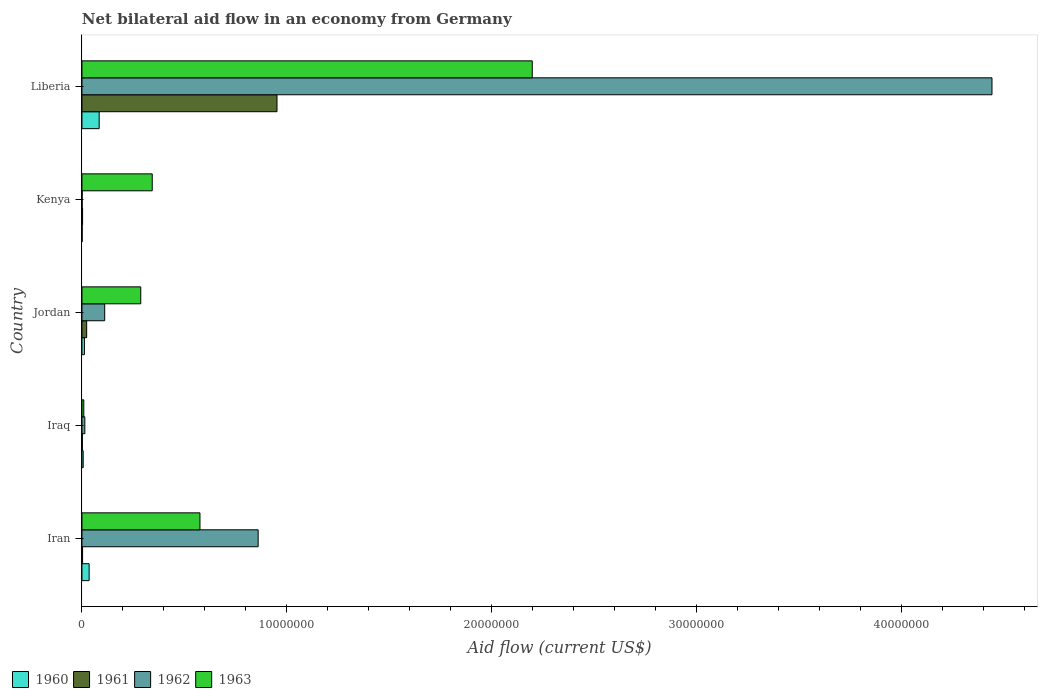How many different coloured bars are there?
Give a very brief answer. 4. Are the number of bars per tick equal to the number of legend labels?
Give a very brief answer. Yes. How many bars are there on the 1st tick from the top?
Your answer should be very brief. 4. What is the label of the 1st group of bars from the top?
Give a very brief answer. Liberia. In how many cases, is the number of bars for a given country not equal to the number of legend labels?
Offer a very short reply. 0. Across all countries, what is the maximum net bilateral aid flow in 1962?
Ensure brevity in your answer.  4.44e+07. In which country was the net bilateral aid flow in 1961 maximum?
Your answer should be very brief. Liberia. In which country was the net bilateral aid flow in 1963 minimum?
Provide a succinct answer. Iraq. What is the total net bilateral aid flow in 1962 in the graph?
Provide a short and direct response. 5.43e+07. What is the difference between the net bilateral aid flow in 1963 in Jordan and the net bilateral aid flow in 1962 in Liberia?
Offer a very short reply. -4.16e+07. What is the average net bilateral aid flow in 1961 per country?
Give a very brief answer. 1.97e+06. What is the difference between the net bilateral aid flow in 1962 and net bilateral aid flow in 1961 in Liberia?
Provide a short and direct response. 3.49e+07. What is the ratio of the net bilateral aid flow in 1962 in Kenya to that in Liberia?
Your answer should be very brief. 0. Is the difference between the net bilateral aid flow in 1962 in Iraq and Jordan greater than the difference between the net bilateral aid flow in 1961 in Iraq and Jordan?
Your answer should be compact. No. What is the difference between the highest and the second highest net bilateral aid flow in 1961?
Make the answer very short. 9.29e+06. What is the difference between the highest and the lowest net bilateral aid flow in 1960?
Your answer should be very brief. 8.30e+05. Is it the case that in every country, the sum of the net bilateral aid flow in 1961 and net bilateral aid flow in 1962 is greater than the sum of net bilateral aid flow in 1960 and net bilateral aid flow in 1963?
Ensure brevity in your answer.  No. What does the 3rd bar from the top in Iraq represents?
Provide a succinct answer. 1961. Is it the case that in every country, the sum of the net bilateral aid flow in 1961 and net bilateral aid flow in 1963 is greater than the net bilateral aid flow in 1960?
Provide a short and direct response. Yes. Are all the bars in the graph horizontal?
Make the answer very short. Yes. Are the values on the major ticks of X-axis written in scientific E-notation?
Offer a very short reply. No. Where does the legend appear in the graph?
Keep it short and to the point. Bottom left. How many legend labels are there?
Your answer should be very brief. 4. What is the title of the graph?
Ensure brevity in your answer.  Net bilateral aid flow in an economy from Germany. What is the Aid flow (current US$) of 1960 in Iran?
Your answer should be very brief. 3.50e+05. What is the Aid flow (current US$) in 1961 in Iran?
Offer a very short reply. 3.00e+04. What is the Aid flow (current US$) in 1962 in Iran?
Make the answer very short. 8.60e+06. What is the Aid flow (current US$) in 1963 in Iran?
Ensure brevity in your answer.  5.76e+06. What is the Aid flow (current US$) of 1963 in Iraq?
Your answer should be compact. 9.00e+04. What is the Aid flow (current US$) in 1960 in Jordan?
Give a very brief answer. 1.20e+05. What is the Aid flow (current US$) of 1962 in Jordan?
Make the answer very short. 1.11e+06. What is the Aid flow (current US$) of 1963 in Jordan?
Provide a short and direct response. 2.87e+06. What is the Aid flow (current US$) in 1960 in Kenya?
Give a very brief answer. 10000. What is the Aid flow (current US$) of 1963 in Kenya?
Your response must be concise. 3.43e+06. What is the Aid flow (current US$) in 1960 in Liberia?
Offer a very short reply. 8.40e+05. What is the Aid flow (current US$) in 1961 in Liberia?
Provide a short and direct response. 9.52e+06. What is the Aid flow (current US$) of 1962 in Liberia?
Make the answer very short. 4.44e+07. What is the Aid flow (current US$) of 1963 in Liberia?
Give a very brief answer. 2.20e+07. Across all countries, what is the maximum Aid flow (current US$) of 1960?
Provide a succinct answer. 8.40e+05. Across all countries, what is the maximum Aid flow (current US$) in 1961?
Keep it short and to the point. 9.52e+06. Across all countries, what is the maximum Aid flow (current US$) of 1962?
Your answer should be very brief. 4.44e+07. Across all countries, what is the maximum Aid flow (current US$) in 1963?
Provide a succinct answer. 2.20e+07. Across all countries, what is the minimum Aid flow (current US$) of 1962?
Your answer should be very brief. 10000. What is the total Aid flow (current US$) of 1960 in the graph?
Provide a short and direct response. 1.38e+06. What is the total Aid flow (current US$) of 1961 in the graph?
Make the answer very short. 9.83e+06. What is the total Aid flow (current US$) of 1962 in the graph?
Offer a terse response. 5.43e+07. What is the total Aid flow (current US$) in 1963 in the graph?
Keep it short and to the point. 3.41e+07. What is the difference between the Aid flow (current US$) in 1962 in Iran and that in Iraq?
Provide a short and direct response. 8.46e+06. What is the difference between the Aid flow (current US$) of 1963 in Iran and that in Iraq?
Provide a succinct answer. 5.67e+06. What is the difference between the Aid flow (current US$) of 1962 in Iran and that in Jordan?
Your answer should be very brief. 7.49e+06. What is the difference between the Aid flow (current US$) in 1963 in Iran and that in Jordan?
Your answer should be very brief. 2.89e+06. What is the difference between the Aid flow (current US$) of 1961 in Iran and that in Kenya?
Provide a succinct answer. 0. What is the difference between the Aid flow (current US$) of 1962 in Iran and that in Kenya?
Offer a terse response. 8.59e+06. What is the difference between the Aid flow (current US$) in 1963 in Iran and that in Kenya?
Ensure brevity in your answer.  2.33e+06. What is the difference between the Aid flow (current US$) in 1960 in Iran and that in Liberia?
Your answer should be very brief. -4.90e+05. What is the difference between the Aid flow (current US$) of 1961 in Iran and that in Liberia?
Keep it short and to the point. -9.49e+06. What is the difference between the Aid flow (current US$) of 1962 in Iran and that in Liberia?
Offer a very short reply. -3.58e+07. What is the difference between the Aid flow (current US$) of 1963 in Iran and that in Liberia?
Your answer should be very brief. -1.62e+07. What is the difference between the Aid flow (current US$) of 1960 in Iraq and that in Jordan?
Make the answer very short. -6.00e+04. What is the difference between the Aid flow (current US$) in 1962 in Iraq and that in Jordan?
Provide a short and direct response. -9.70e+05. What is the difference between the Aid flow (current US$) of 1963 in Iraq and that in Jordan?
Your answer should be very brief. -2.78e+06. What is the difference between the Aid flow (current US$) of 1960 in Iraq and that in Kenya?
Your answer should be compact. 5.00e+04. What is the difference between the Aid flow (current US$) of 1961 in Iraq and that in Kenya?
Your answer should be compact. -10000. What is the difference between the Aid flow (current US$) in 1962 in Iraq and that in Kenya?
Offer a terse response. 1.30e+05. What is the difference between the Aid flow (current US$) of 1963 in Iraq and that in Kenya?
Offer a terse response. -3.34e+06. What is the difference between the Aid flow (current US$) in 1960 in Iraq and that in Liberia?
Provide a short and direct response. -7.80e+05. What is the difference between the Aid flow (current US$) in 1961 in Iraq and that in Liberia?
Your answer should be very brief. -9.50e+06. What is the difference between the Aid flow (current US$) of 1962 in Iraq and that in Liberia?
Provide a succinct answer. -4.43e+07. What is the difference between the Aid flow (current US$) of 1963 in Iraq and that in Liberia?
Give a very brief answer. -2.19e+07. What is the difference between the Aid flow (current US$) of 1961 in Jordan and that in Kenya?
Keep it short and to the point. 2.00e+05. What is the difference between the Aid flow (current US$) in 1962 in Jordan and that in Kenya?
Provide a short and direct response. 1.10e+06. What is the difference between the Aid flow (current US$) in 1963 in Jordan and that in Kenya?
Ensure brevity in your answer.  -5.60e+05. What is the difference between the Aid flow (current US$) of 1960 in Jordan and that in Liberia?
Offer a very short reply. -7.20e+05. What is the difference between the Aid flow (current US$) in 1961 in Jordan and that in Liberia?
Give a very brief answer. -9.29e+06. What is the difference between the Aid flow (current US$) of 1962 in Jordan and that in Liberia?
Your answer should be compact. -4.33e+07. What is the difference between the Aid flow (current US$) of 1963 in Jordan and that in Liberia?
Offer a terse response. -1.91e+07. What is the difference between the Aid flow (current US$) of 1960 in Kenya and that in Liberia?
Ensure brevity in your answer.  -8.30e+05. What is the difference between the Aid flow (current US$) of 1961 in Kenya and that in Liberia?
Your answer should be very brief. -9.49e+06. What is the difference between the Aid flow (current US$) of 1962 in Kenya and that in Liberia?
Provide a succinct answer. -4.44e+07. What is the difference between the Aid flow (current US$) of 1963 in Kenya and that in Liberia?
Make the answer very short. -1.86e+07. What is the difference between the Aid flow (current US$) of 1960 in Iran and the Aid flow (current US$) of 1963 in Iraq?
Your response must be concise. 2.60e+05. What is the difference between the Aid flow (current US$) in 1961 in Iran and the Aid flow (current US$) in 1963 in Iraq?
Your answer should be very brief. -6.00e+04. What is the difference between the Aid flow (current US$) of 1962 in Iran and the Aid flow (current US$) of 1963 in Iraq?
Your response must be concise. 8.51e+06. What is the difference between the Aid flow (current US$) of 1960 in Iran and the Aid flow (current US$) of 1962 in Jordan?
Make the answer very short. -7.60e+05. What is the difference between the Aid flow (current US$) in 1960 in Iran and the Aid flow (current US$) in 1963 in Jordan?
Offer a very short reply. -2.52e+06. What is the difference between the Aid flow (current US$) of 1961 in Iran and the Aid flow (current US$) of 1962 in Jordan?
Your answer should be compact. -1.08e+06. What is the difference between the Aid flow (current US$) in 1961 in Iran and the Aid flow (current US$) in 1963 in Jordan?
Provide a succinct answer. -2.84e+06. What is the difference between the Aid flow (current US$) of 1962 in Iran and the Aid flow (current US$) of 1963 in Jordan?
Offer a very short reply. 5.73e+06. What is the difference between the Aid flow (current US$) in 1960 in Iran and the Aid flow (current US$) in 1962 in Kenya?
Ensure brevity in your answer.  3.40e+05. What is the difference between the Aid flow (current US$) of 1960 in Iran and the Aid flow (current US$) of 1963 in Kenya?
Offer a terse response. -3.08e+06. What is the difference between the Aid flow (current US$) of 1961 in Iran and the Aid flow (current US$) of 1963 in Kenya?
Your answer should be compact. -3.40e+06. What is the difference between the Aid flow (current US$) in 1962 in Iran and the Aid flow (current US$) in 1963 in Kenya?
Make the answer very short. 5.17e+06. What is the difference between the Aid flow (current US$) of 1960 in Iran and the Aid flow (current US$) of 1961 in Liberia?
Offer a terse response. -9.17e+06. What is the difference between the Aid flow (current US$) in 1960 in Iran and the Aid flow (current US$) in 1962 in Liberia?
Keep it short and to the point. -4.41e+07. What is the difference between the Aid flow (current US$) of 1960 in Iran and the Aid flow (current US$) of 1963 in Liberia?
Make the answer very short. -2.16e+07. What is the difference between the Aid flow (current US$) of 1961 in Iran and the Aid flow (current US$) of 1962 in Liberia?
Your answer should be compact. -4.44e+07. What is the difference between the Aid flow (current US$) in 1961 in Iran and the Aid flow (current US$) in 1963 in Liberia?
Your answer should be very brief. -2.20e+07. What is the difference between the Aid flow (current US$) in 1962 in Iran and the Aid flow (current US$) in 1963 in Liberia?
Give a very brief answer. -1.34e+07. What is the difference between the Aid flow (current US$) in 1960 in Iraq and the Aid flow (current US$) in 1962 in Jordan?
Offer a terse response. -1.05e+06. What is the difference between the Aid flow (current US$) in 1960 in Iraq and the Aid flow (current US$) in 1963 in Jordan?
Offer a terse response. -2.81e+06. What is the difference between the Aid flow (current US$) of 1961 in Iraq and the Aid flow (current US$) of 1962 in Jordan?
Ensure brevity in your answer.  -1.09e+06. What is the difference between the Aid flow (current US$) in 1961 in Iraq and the Aid flow (current US$) in 1963 in Jordan?
Give a very brief answer. -2.85e+06. What is the difference between the Aid flow (current US$) in 1962 in Iraq and the Aid flow (current US$) in 1963 in Jordan?
Ensure brevity in your answer.  -2.73e+06. What is the difference between the Aid flow (current US$) of 1960 in Iraq and the Aid flow (current US$) of 1961 in Kenya?
Your answer should be very brief. 3.00e+04. What is the difference between the Aid flow (current US$) of 1960 in Iraq and the Aid flow (current US$) of 1963 in Kenya?
Give a very brief answer. -3.37e+06. What is the difference between the Aid flow (current US$) in 1961 in Iraq and the Aid flow (current US$) in 1962 in Kenya?
Provide a short and direct response. 10000. What is the difference between the Aid flow (current US$) of 1961 in Iraq and the Aid flow (current US$) of 1963 in Kenya?
Offer a very short reply. -3.41e+06. What is the difference between the Aid flow (current US$) of 1962 in Iraq and the Aid flow (current US$) of 1963 in Kenya?
Give a very brief answer. -3.29e+06. What is the difference between the Aid flow (current US$) of 1960 in Iraq and the Aid flow (current US$) of 1961 in Liberia?
Your answer should be compact. -9.46e+06. What is the difference between the Aid flow (current US$) in 1960 in Iraq and the Aid flow (current US$) in 1962 in Liberia?
Provide a succinct answer. -4.44e+07. What is the difference between the Aid flow (current US$) of 1960 in Iraq and the Aid flow (current US$) of 1963 in Liberia?
Provide a succinct answer. -2.19e+07. What is the difference between the Aid flow (current US$) of 1961 in Iraq and the Aid flow (current US$) of 1962 in Liberia?
Your response must be concise. -4.44e+07. What is the difference between the Aid flow (current US$) in 1961 in Iraq and the Aid flow (current US$) in 1963 in Liberia?
Give a very brief answer. -2.20e+07. What is the difference between the Aid flow (current US$) of 1962 in Iraq and the Aid flow (current US$) of 1963 in Liberia?
Give a very brief answer. -2.18e+07. What is the difference between the Aid flow (current US$) of 1960 in Jordan and the Aid flow (current US$) of 1963 in Kenya?
Ensure brevity in your answer.  -3.31e+06. What is the difference between the Aid flow (current US$) of 1961 in Jordan and the Aid flow (current US$) of 1962 in Kenya?
Provide a short and direct response. 2.20e+05. What is the difference between the Aid flow (current US$) in 1961 in Jordan and the Aid flow (current US$) in 1963 in Kenya?
Make the answer very short. -3.20e+06. What is the difference between the Aid flow (current US$) in 1962 in Jordan and the Aid flow (current US$) in 1963 in Kenya?
Keep it short and to the point. -2.32e+06. What is the difference between the Aid flow (current US$) in 1960 in Jordan and the Aid flow (current US$) in 1961 in Liberia?
Offer a terse response. -9.40e+06. What is the difference between the Aid flow (current US$) of 1960 in Jordan and the Aid flow (current US$) of 1962 in Liberia?
Your response must be concise. -4.43e+07. What is the difference between the Aid flow (current US$) in 1960 in Jordan and the Aid flow (current US$) in 1963 in Liberia?
Give a very brief answer. -2.19e+07. What is the difference between the Aid flow (current US$) in 1961 in Jordan and the Aid flow (current US$) in 1962 in Liberia?
Your answer should be very brief. -4.42e+07. What is the difference between the Aid flow (current US$) of 1961 in Jordan and the Aid flow (current US$) of 1963 in Liberia?
Provide a succinct answer. -2.18e+07. What is the difference between the Aid flow (current US$) in 1962 in Jordan and the Aid flow (current US$) in 1963 in Liberia?
Offer a very short reply. -2.09e+07. What is the difference between the Aid flow (current US$) of 1960 in Kenya and the Aid flow (current US$) of 1961 in Liberia?
Ensure brevity in your answer.  -9.51e+06. What is the difference between the Aid flow (current US$) of 1960 in Kenya and the Aid flow (current US$) of 1962 in Liberia?
Provide a succinct answer. -4.44e+07. What is the difference between the Aid flow (current US$) in 1960 in Kenya and the Aid flow (current US$) in 1963 in Liberia?
Your answer should be very brief. -2.20e+07. What is the difference between the Aid flow (current US$) in 1961 in Kenya and the Aid flow (current US$) in 1962 in Liberia?
Offer a very short reply. -4.44e+07. What is the difference between the Aid flow (current US$) in 1961 in Kenya and the Aid flow (current US$) in 1963 in Liberia?
Keep it short and to the point. -2.20e+07. What is the difference between the Aid flow (current US$) in 1962 in Kenya and the Aid flow (current US$) in 1963 in Liberia?
Offer a terse response. -2.20e+07. What is the average Aid flow (current US$) in 1960 per country?
Offer a very short reply. 2.76e+05. What is the average Aid flow (current US$) of 1961 per country?
Your response must be concise. 1.97e+06. What is the average Aid flow (current US$) of 1962 per country?
Make the answer very short. 1.09e+07. What is the average Aid flow (current US$) of 1963 per country?
Provide a short and direct response. 6.83e+06. What is the difference between the Aid flow (current US$) in 1960 and Aid flow (current US$) in 1962 in Iran?
Give a very brief answer. -8.25e+06. What is the difference between the Aid flow (current US$) in 1960 and Aid flow (current US$) in 1963 in Iran?
Offer a very short reply. -5.41e+06. What is the difference between the Aid flow (current US$) of 1961 and Aid flow (current US$) of 1962 in Iran?
Keep it short and to the point. -8.57e+06. What is the difference between the Aid flow (current US$) in 1961 and Aid flow (current US$) in 1963 in Iran?
Offer a terse response. -5.73e+06. What is the difference between the Aid flow (current US$) in 1962 and Aid flow (current US$) in 1963 in Iran?
Your response must be concise. 2.84e+06. What is the difference between the Aid flow (current US$) in 1960 and Aid flow (current US$) in 1961 in Iraq?
Offer a very short reply. 4.00e+04. What is the difference between the Aid flow (current US$) of 1960 and Aid flow (current US$) of 1963 in Iraq?
Provide a succinct answer. -3.00e+04. What is the difference between the Aid flow (current US$) in 1961 and Aid flow (current US$) in 1962 in Iraq?
Keep it short and to the point. -1.20e+05. What is the difference between the Aid flow (current US$) of 1961 and Aid flow (current US$) of 1963 in Iraq?
Provide a succinct answer. -7.00e+04. What is the difference between the Aid flow (current US$) in 1960 and Aid flow (current US$) in 1962 in Jordan?
Provide a succinct answer. -9.90e+05. What is the difference between the Aid flow (current US$) in 1960 and Aid flow (current US$) in 1963 in Jordan?
Give a very brief answer. -2.75e+06. What is the difference between the Aid flow (current US$) in 1961 and Aid flow (current US$) in 1962 in Jordan?
Provide a succinct answer. -8.80e+05. What is the difference between the Aid flow (current US$) of 1961 and Aid flow (current US$) of 1963 in Jordan?
Make the answer very short. -2.64e+06. What is the difference between the Aid flow (current US$) of 1962 and Aid flow (current US$) of 1963 in Jordan?
Make the answer very short. -1.76e+06. What is the difference between the Aid flow (current US$) in 1960 and Aid flow (current US$) in 1961 in Kenya?
Ensure brevity in your answer.  -2.00e+04. What is the difference between the Aid flow (current US$) of 1960 and Aid flow (current US$) of 1962 in Kenya?
Offer a terse response. 0. What is the difference between the Aid flow (current US$) in 1960 and Aid flow (current US$) in 1963 in Kenya?
Provide a short and direct response. -3.42e+06. What is the difference between the Aid flow (current US$) in 1961 and Aid flow (current US$) in 1963 in Kenya?
Your answer should be compact. -3.40e+06. What is the difference between the Aid flow (current US$) in 1962 and Aid flow (current US$) in 1963 in Kenya?
Make the answer very short. -3.42e+06. What is the difference between the Aid flow (current US$) in 1960 and Aid flow (current US$) in 1961 in Liberia?
Your answer should be very brief. -8.68e+06. What is the difference between the Aid flow (current US$) of 1960 and Aid flow (current US$) of 1962 in Liberia?
Ensure brevity in your answer.  -4.36e+07. What is the difference between the Aid flow (current US$) of 1960 and Aid flow (current US$) of 1963 in Liberia?
Offer a very short reply. -2.11e+07. What is the difference between the Aid flow (current US$) of 1961 and Aid flow (current US$) of 1962 in Liberia?
Provide a short and direct response. -3.49e+07. What is the difference between the Aid flow (current US$) of 1961 and Aid flow (current US$) of 1963 in Liberia?
Keep it short and to the point. -1.25e+07. What is the difference between the Aid flow (current US$) in 1962 and Aid flow (current US$) in 1963 in Liberia?
Your answer should be compact. 2.24e+07. What is the ratio of the Aid flow (current US$) of 1960 in Iran to that in Iraq?
Offer a terse response. 5.83. What is the ratio of the Aid flow (current US$) of 1961 in Iran to that in Iraq?
Your answer should be very brief. 1.5. What is the ratio of the Aid flow (current US$) in 1962 in Iran to that in Iraq?
Offer a very short reply. 61.43. What is the ratio of the Aid flow (current US$) in 1960 in Iran to that in Jordan?
Give a very brief answer. 2.92. What is the ratio of the Aid flow (current US$) in 1961 in Iran to that in Jordan?
Provide a succinct answer. 0.13. What is the ratio of the Aid flow (current US$) of 1962 in Iran to that in Jordan?
Provide a succinct answer. 7.75. What is the ratio of the Aid flow (current US$) in 1963 in Iran to that in Jordan?
Provide a succinct answer. 2.01. What is the ratio of the Aid flow (current US$) of 1961 in Iran to that in Kenya?
Your response must be concise. 1. What is the ratio of the Aid flow (current US$) in 1962 in Iran to that in Kenya?
Provide a short and direct response. 860. What is the ratio of the Aid flow (current US$) of 1963 in Iran to that in Kenya?
Your answer should be very brief. 1.68. What is the ratio of the Aid flow (current US$) of 1960 in Iran to that in Liberia?
Your answer should be compact. 0.42. What is the ratio of the Aid flow (current US$) in 1961 in Iran to that in Liberia?
Offer a very short reply. 0. What is the ratio of the Aid flow (current US$) in 1962 in Iran to that in Liberia?
Your answer should be compact. 0.19. What is the ratio of the Aid flow (current US$) in 1963 in Iran to that in Liberia?
Provide a short and direct response. 0.26. What is the ratio of the Aid flow (current US$) of 1960 in Iraq to that in Jordan?
Keep it short and to the point. 0.5. What is the ratio of the Aid flow (current US$) in 1961 in Iraq to that in Jordan?
Provide a short and direct response. 0.09. What is the ratio of the Aid flow (current US$) of 1962 in Iraq to that in Jordan?
Give a very brief answer. 0.13. What is the ratio of the Aid flow (current US$) in 1963 in Iraq to that in Jordan?
Your answer should be compact. 0.03. What is the ratio of the Aid flow (current US$) in 1963 in Iraq to that in Kenya?
Offer a terse response. 0.03. What is the ratio of the Aid flow (current US$) in 1960 in Iraq to that in Liberia?
Provide a short and direct response. 0.07. What is the ratio of the Aid flow (current US$) in 1961 in Iraq to that in Liberia?
Offer a terse response. 0. What is the ratio of the Aid flow (current US$) in 1962 in Iraq to that in Liberia?
Keep it short and to the point. 0. What is the ratio of the Aid flow (current US$) of 1963 in Iraq to that in Liberia?
Make the answer very short. 0. What is the ratio of the Aid flow (current US$) of 1960 in Jordan to that in Kenya?
Offer a terse response. 12. What is the ratio of the Aid flow (current US$) of 1961 in Jordan to that in Kenya?
Give a very brief answer. 7.67. What is the ratio of the Aid flow (current US$) in 1962 in Jordan to that in Kenya?
Provide a succinct answer. 111. What is the ratio of the Aid flow (current US$) of 1963 in Jordan to that in Kenya?
Provide a succinct answer. 0.84. What is the ratio of the Aid flow (current US$) of 1960 in Jordan to that in Liberia?
Offer a very short reply. 0.14. What is the ratio of the Aid flow (current US$) of 1961 in Jordan to that in Liberia?
Keep it short and to the point. 0.02. What is the ratio of the Aid flow (current US$) of 1962 in Jordan to that in Liberia?
Offer a terse response. 0.03. What is the ratio of the Aid flow (current US$) in 1963 in Jordan to that in Liberia?
Your response must be concise. 0.13. What is the ratio of the Aid flow (current US$) of 1960 in Kenya to that in Liberia?
Provide a short and direct response. 0.01. What is the ratio of the Aid flow (current US$) in 1961 in Kenya to that in Liberia?
Provide a short and direct response. 0. What is the ratio of the Aid flow (current US$) of 1963 in Kenya to that in Liberia?
Your answer should be compact. 0.16. What is the difference between the highest and the second highest Aid flow (current US$) of 1960?
Offer a terse response. 4.90e+05. What is the difference between the highest and the second highest Aid flow (current US$) of 1961?
Ensure brevity in your answer.  9.29e+06. What is the difference between the highest and the second highest Aid flow (current US$) of 1962?
Make the answer very short. 3.58e+07. What is the difference between the highest and the second highest Aid flow (current US$) of 1963?
Offer a terse response. 1.62e+07. What is the difference between the highest and the lowest Aid flow (current US$) in 1960?
Give a very brief answer. 8.30e+05. What is the difference between the highest and the lowest Aid flow (current US$) in 1961?
Provide a short and direct response. 9.50e+06. What is the difference between the highest and the lowest Aid flow (current US$) in 1962?
Keep it short and to the point. 4.44e+07. What is the difference between the highest and the lowest Aid flow (current US$) of 1963?
Offer a very short reply. 2.19e+07. 